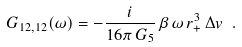<formula> <loc_0><loc_0><loc_500><loc_500>G _ { 1 2 , 1 2 } ( \omega ) = - \frac { i } { 1 6 \pi \, G _ { 5 } } \, \beta \, \omega \, r _ { + } ^ { 3 } \, \Delta v \ .</formula> 